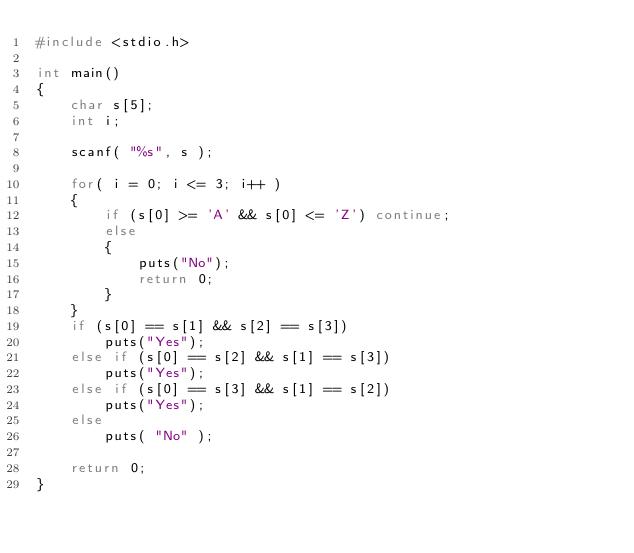Convert code to text. <code><loc_0><loc_0><loc_500><loc_500><_C_>#include <stdio.h>

int main()
{
    char s[5];
    int i;

    scanf( "%s", s );
    
    for( i = 0; i <= 3; i++ )
    {
        if (s[0] >= 'A' && s[0] <= 'Z') continue;
        else 
        {
            puts("No");
            return 0;
        }
    }
    if (s[0] == s[1] && s[2] == s[3])
        puts("Yes");
    else if (s[0] == s[2] && s[1] == s[3])
        puts("Yes");
    else if (s[0] == s[3] && s[1] == s[2])
        puts("Yes");
    else
        puts( "No" );
    
    return 0;
}</code> 